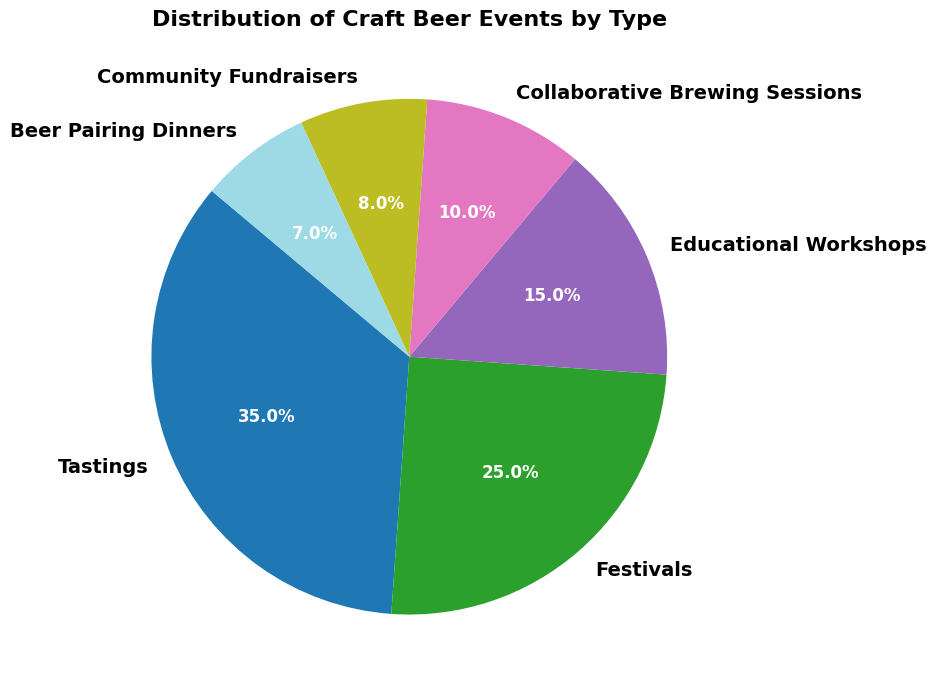Which type of craft beer event is the most common? The pie chart shows "Tastings" has the largest segment. This indicates it is the most common type of craft beer event.
Answer: Tastings What percentage of craft beer events are Festivals? The segment labeled "Festivals" shows its percentage.
Answer: 25% How much greater is the percentage of Tastings compared to Educational Workshops? Subtract the percentage of Educational Workshops (15) from the percentage of Tastings (35). 35 - 15 = 20.
Answer: 20% What percentage of craft beer events is composed of Community Fundraisers and Beer Pairing Dinners combined? Add the percentages of Community Fundraisers (8) and Beer Pairing Dinners (7). 8 + 7 = 15.
Answer: 15% Are there more Educational Workshops or Collaborative Brewing Sessions? Compare the segments labeled "Educational Workshops" (15%) and "Collaborative Brewing Sessions" (10%). 15% is greater than 10%.
Answer: Educational Workshops Which two types of craft beer events together make up half of all events? Adding percentages, Tastings (35%) and Festivals (25%) sum to 60%, which is greater than half. The correct pair is "Tastings" (35%) and Educational Workshops (15%), summing to 50%.
Answer: Tastings and Educational Workshops What is the smallest type of craft beer event in terms of percentage? The pie chart section labeled "Beer Pairing Dinners" is the smallest.
Answer: Beer Pairing Dinners How many types of events have a percentage greater than 20%? Check segments with percentages above 20%. Only "Tastings" (35%) and "Festivals" (25%) meet this criterion.
Answer: 2 types Is the percentage of Collaborative Brewing Sessions less than Community Fundraisers? Compare "Collaborative Brewing Sessions" (10%) and "Community Fundraisers" (8%). 10% is greater than 8%.
Answer: No 